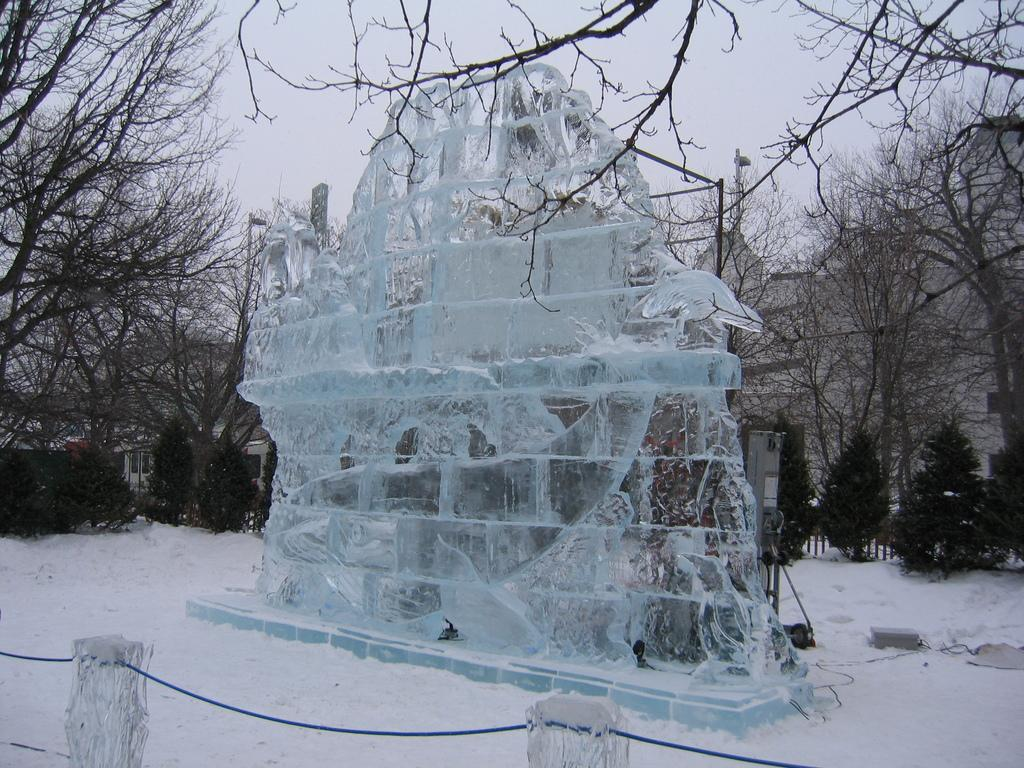What type of building is in the image? There is an ice house in the image. What is the condition of the ground around the ice house? The ground around the ice house is snowy. What can be seen in the vicinity of the ice house? Trees are present around the ice house. What type of brush is used to clean the ice house in the image? There is no brush present in the image, and no cleaning activity is depicted. 